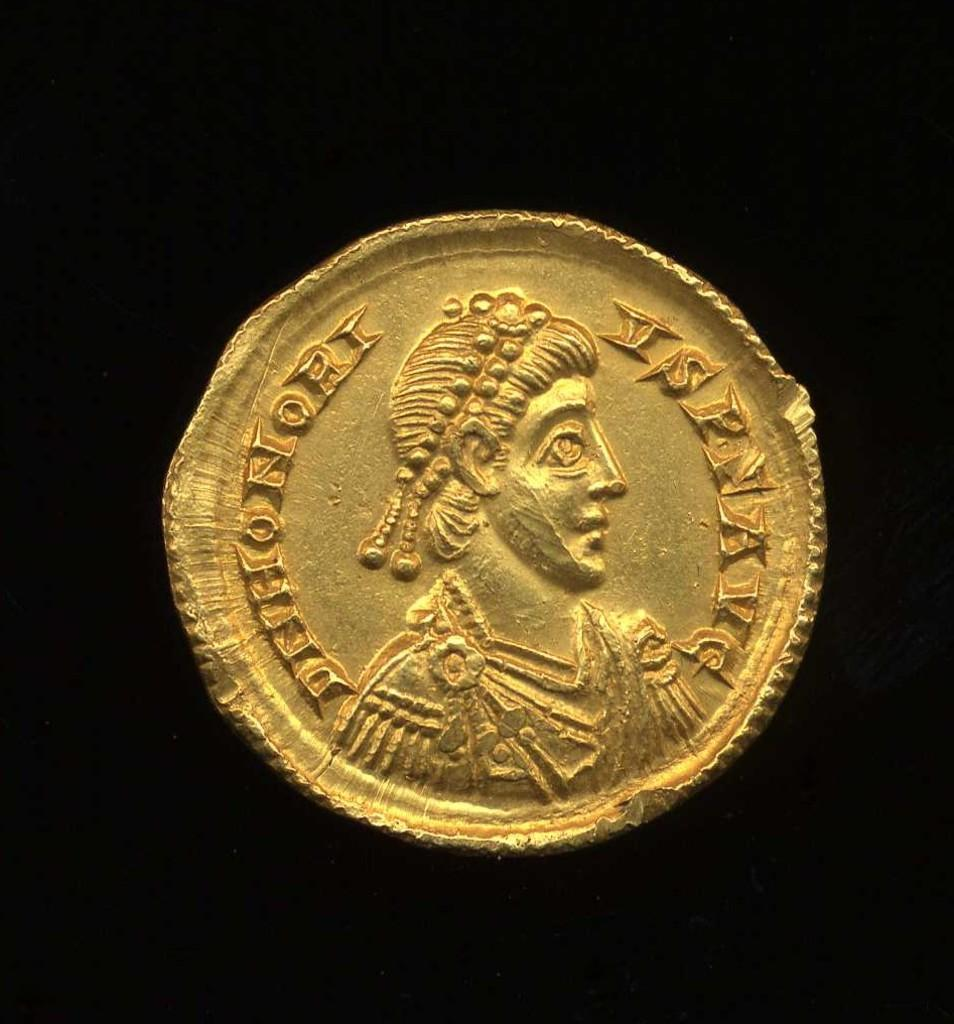What is the main subject of the image? The main subject of the image is a gold coin. Can you describe the background of the image? The background of the image is black. What type of can does the governor use in the image? There is no governor or can present in the image. What is the name of the mark on the gold coin in the image? There is no mark or specific name mentioned for the gold coin in the image. 